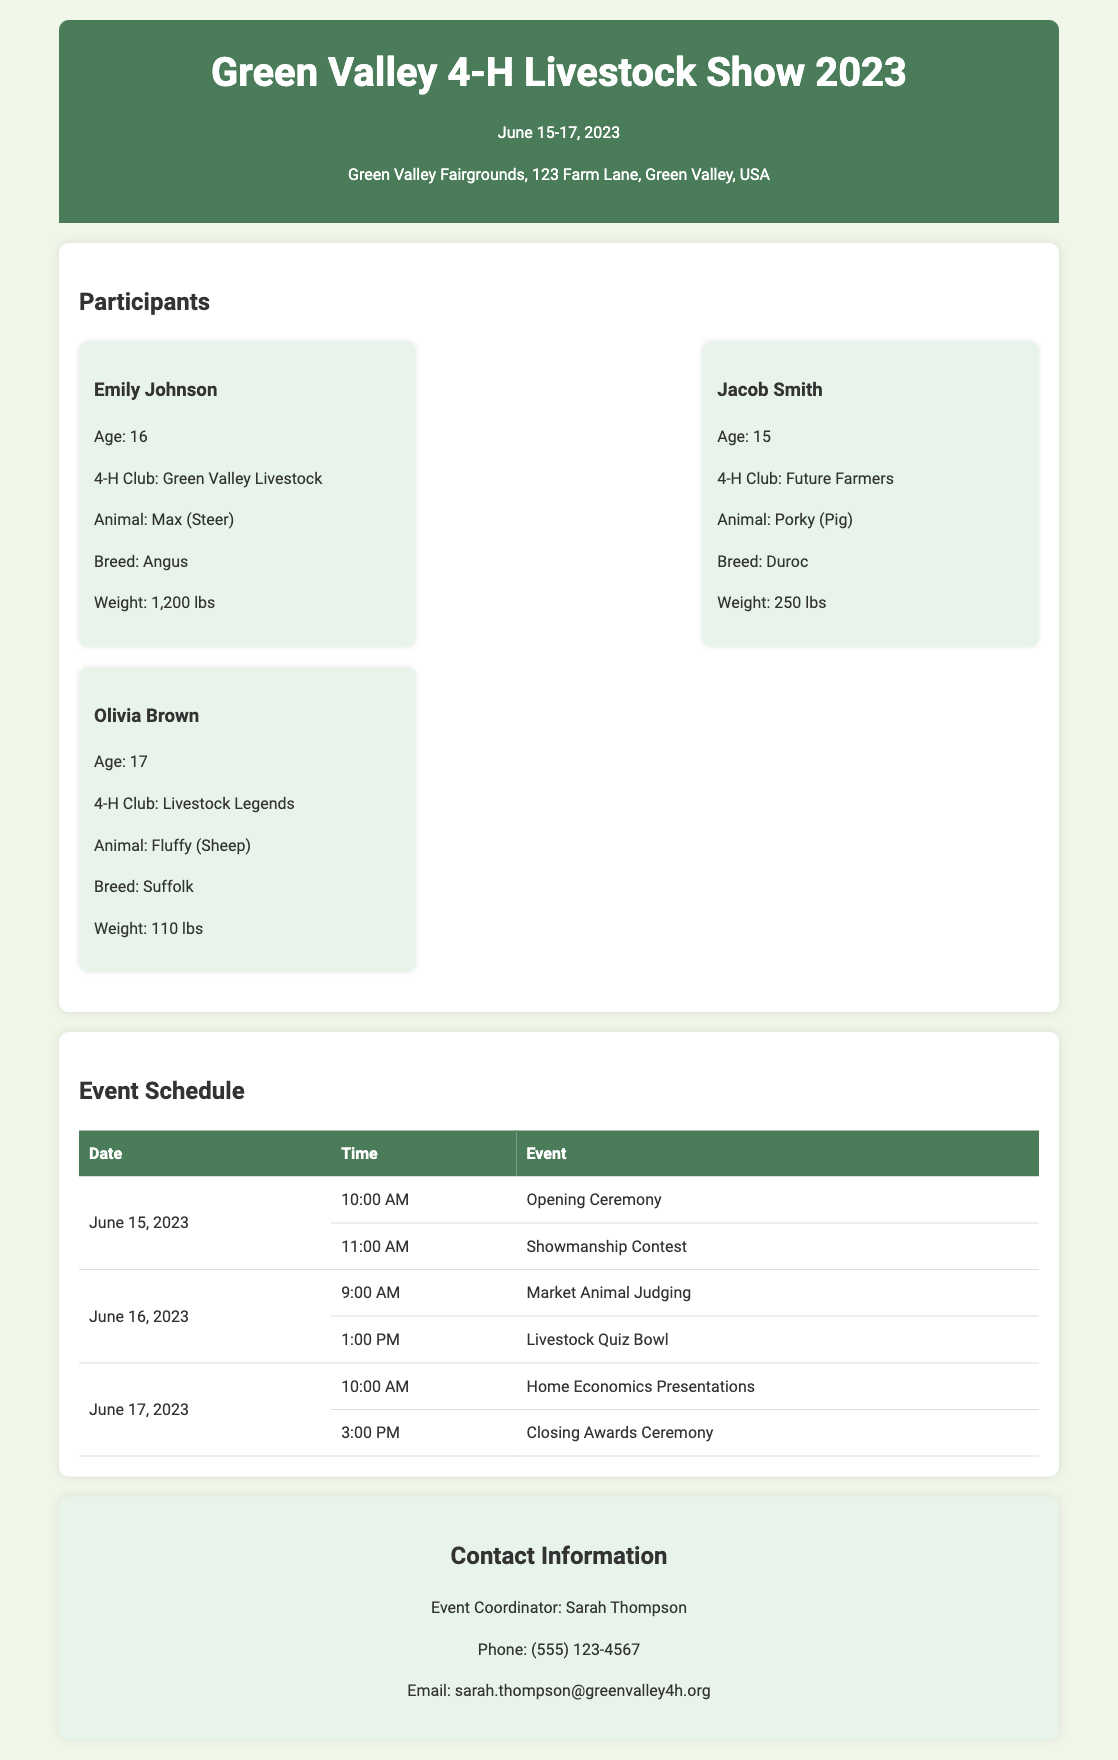What are the event dates? The event dates listed in the document are from June 15 to June 17, 2023.
Answer: June 15-17, 2023 Who is the event coordinator? The event coordinator's name is mentioned in the contact information section of the document.
Answer: Sarah Thompson What is the weight of Max? Max's weight is specified in the participant section under Emily Johnson.
Answer: 1,200 lbs What event starts on June 16, 2023? The event schedule indicates the first event on June 16 is Market Animal Judging.
Answer: Market Animal Judging How old is Jacob Smith? Jacob Smith's age is provided within his participant profile.
Answer: 15 What is Olivia Brown's animal? The document states that Olivia Brown has a sheep as her animal.
Answer: Fluffy (Sheep) At what time is the Closing Awards Ceremony? The time for the Closing Awards Ceremony is detailed in the event schedule section.
Answer: 3:00 PM Which 4-H club does Emily Johnson belong to? Emily Johnson's affiliation is found within her participant details.
Answer: Green Valley Livestock 